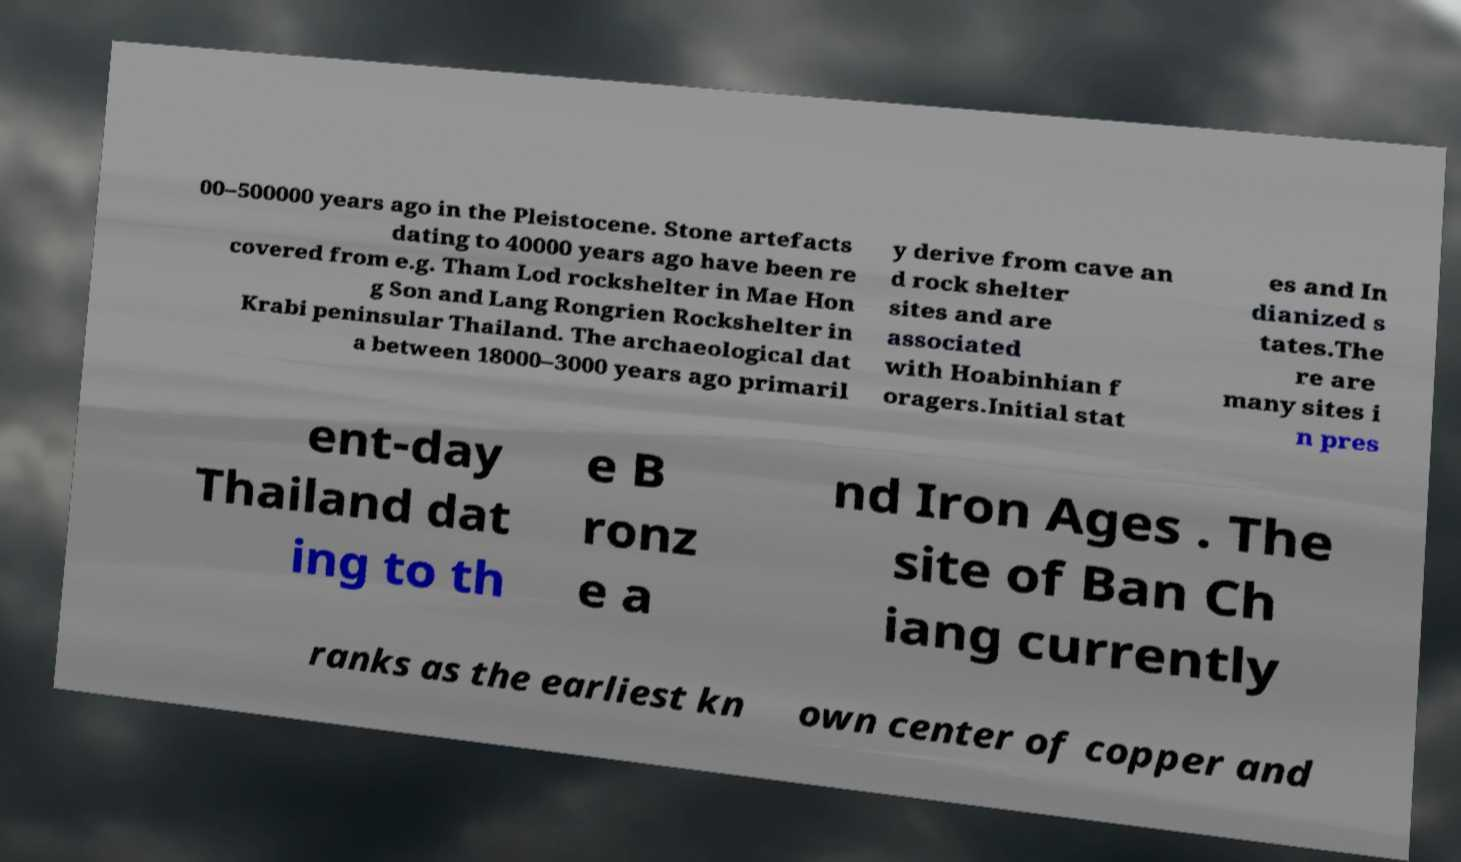Please read and relay the text visible in this image. What does it say? 00–500000 years ago in the Pleistocene. Stone artefacts dating to 40000 years ago have been re covered from e.g. Tham Lod rockshelter in Mae Hon g Son and Lang Rongrien Rockshelter in Krabi peninsular Thailand. The archaeological dat a between 18000–3000 years ago primaril y derive from cave an d rock shelter sites and are associated with Hoabinhian f oragers.Initial stat es and In dianized s tates.The re are many sites i n pres ent-day Thailand dat ing to th e B ronz e a nd Iron Ages . The site of Ban Ch iang currently ranks as the earliest kn own center of copper and 